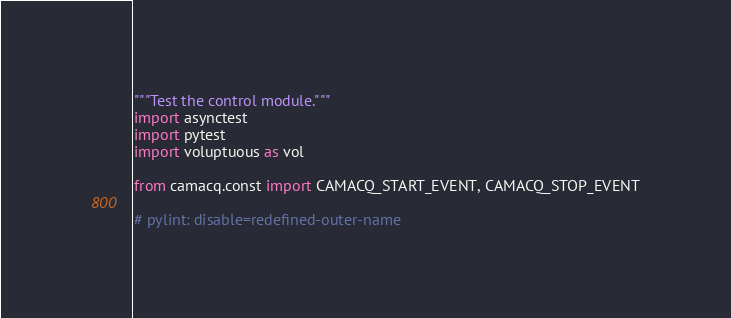Convert code to text. <code><loc_0><loc_0><loc_500><loc_500><_Python_>"""Test the control module."""
import asynctest
import pytest
import voluptuous as vol

from camacq.const import CAMACQ_START_EVENT, CAMACQ_STOP_EVENT

# pylint: disable=redefined-outer-name</code> 